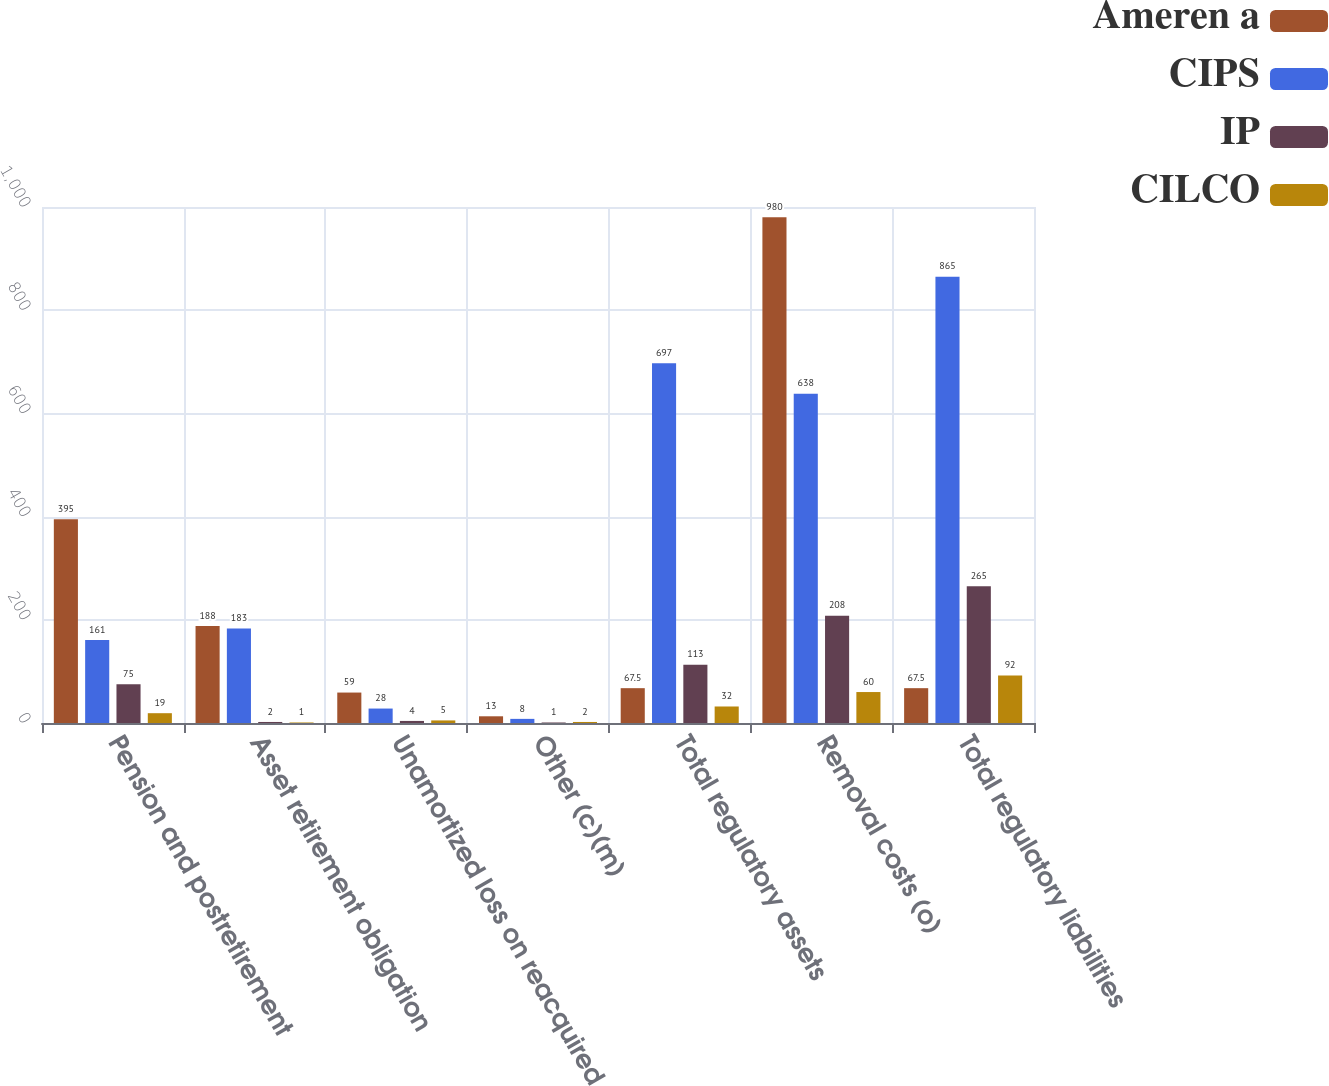Convert chart. <chart><loc_0><loc_0><loc_500><loc_500><stacked_bar_chart><ecel><fcel>Pension and postretirement<fcel>Asset retirement obligation<fcel>Unamortized loss on reacquired<fcel>Other (c)(m)<fcel>Total regulatory assets<fcel>Removal costs (o)<fcel>Total regulatory liabilities<nl><fcel>Ameren a<fcel>395<fcel>188<fcel>59<fcel>13<fcel>67.5<fcel>980<fcel>67.5<nl><fcel>CIPS<fcel>161<fcel>183<fcel>28<fcel>8<fcel>697<fcel>638<fcel>865<nl><fcel>IP<fcel>75<fcel>2<fcel>4<fcel>1<fcel>113<fcel>208<fcel>265<nl><fcel>CILCO<fcel>19<fcel>1<fcel>5<fcel>2<fcel>32<fcel>60<fcel>92<nl></chart> 